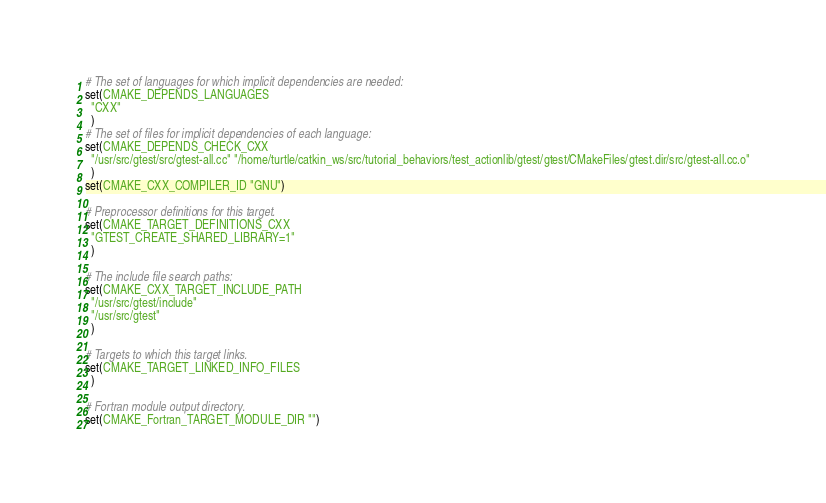Convert code to text. <code><loc_0><loc_0><loc_500><loc_500><_CMake_># The set of languages for which implicit dependencies are needed:
set(CMAKE_DEPENDS_LANGUAGES
  "CXX"
  )
# The set of files for implicit dependencies of each language:
set(CMAKE_DEPENDS_CHECK_CXX
  "/usr/src/gtest/src/gtest-all.cc" "/home/turtle/catkin_ws/src/tutorial_behaviors/test_actionlib/gtest/gtest/CMakeFiles/gtest.dir/src/gtest-all.cc.o"
  )
set(CMAKE_CXX_COMPILER_ID "GNU")

# Preprocessor definitions for this target.
set(CMAKE_TARGET_DEFINITIONS_CXX
  "GTEST_CREATE_SHARED_LIBRARY=1"
  )

# The include file search paths:
set(CMAKE_CXX_TARGET_INCLUDE_PATH
  "/usr/src/gtest/include"
  "/usr/src/gtest"
  )

# Targets to which this target links.
set(CMAKE_TARGET_LINKED_INFO_FILES
  )

# Fortran module output directory.
set(CMAKE_Fortran_TARGET_MODULE_DIR "")
</code> 